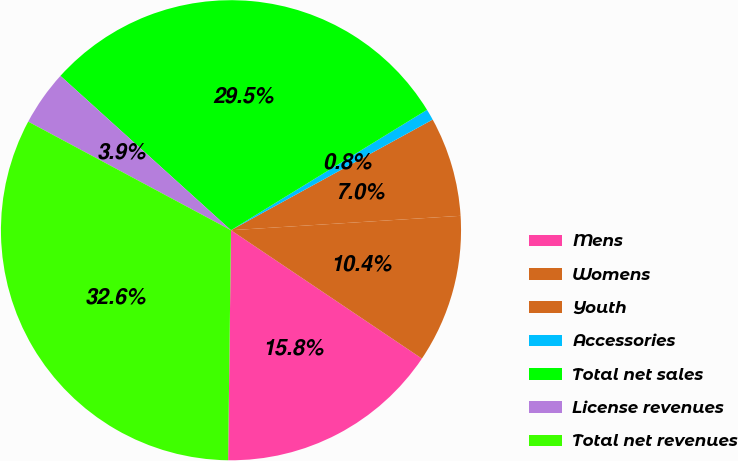<chart> <loc_0><loc_0><loc_500><loc_500><pie_chart><fcel>Mens<fcel>Womens<fcel>Youth<fcel>Accessories<fcel>Total net sales<fcel>License revenues<fcel>Total net revenues<nl><fcel>15.78%<fcel>10.42%<fcel>6.99%<fcel>0.78%<fcel>29.53%<fcel>3.88%<fcel>32.63%<nl></chart> 